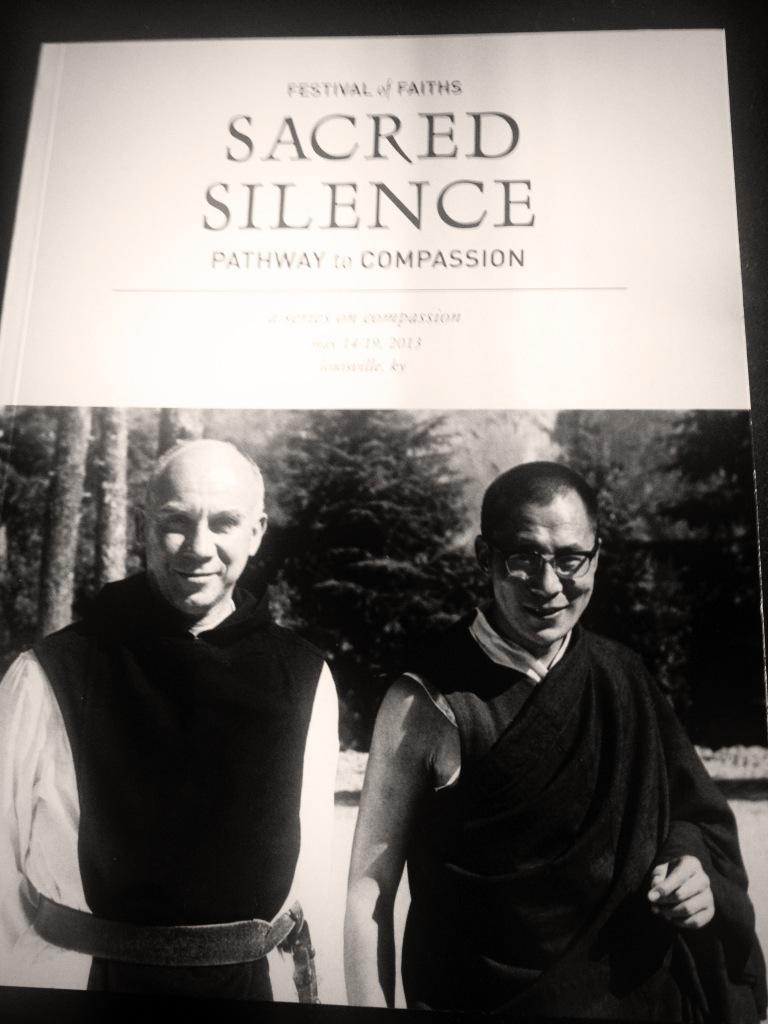What type of visual representation is shown in the image? The image is a poster. What is the main subject of the poster? There is a spectacle depicted on the poster. What type of natural environment is shown on the poster? There are trees on the poster. How many men are featured on the poster, and what are their expressions? There are two men smiling on the poster. What else can be found on the poster besides the visual elements? There is text on the poster. What is the account balance of the man on the left side of the poster? There is no information about an account balance in the image, as it features a spectacle, trees, and text on a poster. What is the weight of the tree on the right side of the poster? There is no weight mentioned for the tree on the poster, as it is a visual representation and not a real tree. 